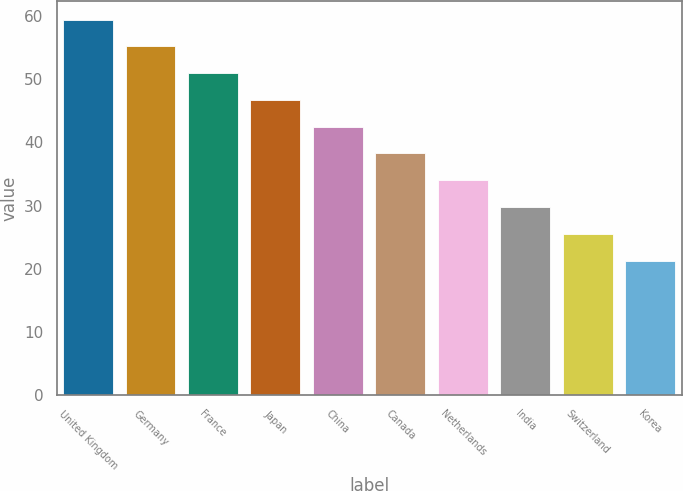Convert chart. <chart><loc_0><loc_0><loc_500><loc_500><bar_chart><fcel>United Kingdom<fcel>Germany<fcel>France<fcel>Japan<fcel>China<fcel>Canada<fcel>Netherlands<fcel>India<fcel>Switzerland<fcel>Korea<nl><fcel>59.39<fcel>55.16<fcel>50.93<fcel>46.7<fcel>42.47<fcel>38.24<fcel>34.01<fcel>29.78<fcel>25.55<fcel>21.32<nl></chart> 